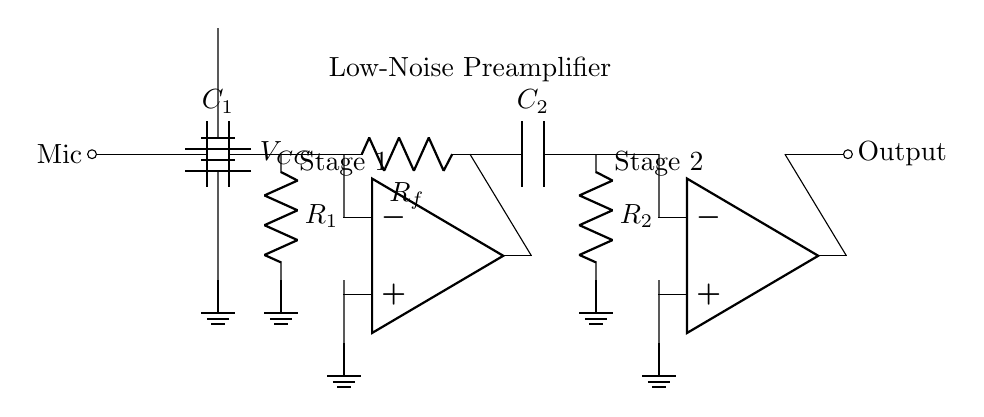What is the component at the input? The input consists of a microphone, depicted as "Mic," connecting to a capacitor labeled C1.
Answer: Microphone What is the purpose of the capacitors C1 and C2 in this circuit? Capacitors C1 and C2 are used to block DC while allowing AC signals (audio signals) to pass, which is essential for amplifying audio without biasing the input.
Answer: Coupling How many operational amplifiers are present in this circuit? There are two operational amplifiers used in the circuit, both are clearly labeled as op amp in the diagram.
Answer: Two What is the feedback resistor labeled in the first stage? The feedback resistor in the first stage is labeled as Rf, connecting the output of the first op-amp back to its inverting input.
Answer: Rf What is the voltage supply used in this circuit? The voltage supply is labeled VCC, which is represented in the diagram as a battery providing power to the amplifier circuit.
Answer: VCC What type of amplifier is described by this circuit? This circuit is a low-noise preamplifier, designed specifically for enhancing the quality of low-level audio signals from microphones in audiometric testing.
Answer: Low-noise preamplifier What does the label "Stage 1" signify in the circuit diagram? The label "Stage 1" indicates the first amplification section, where the initial signal amplification occurs using the first operational amplifier.
Answer: Initial amplification 